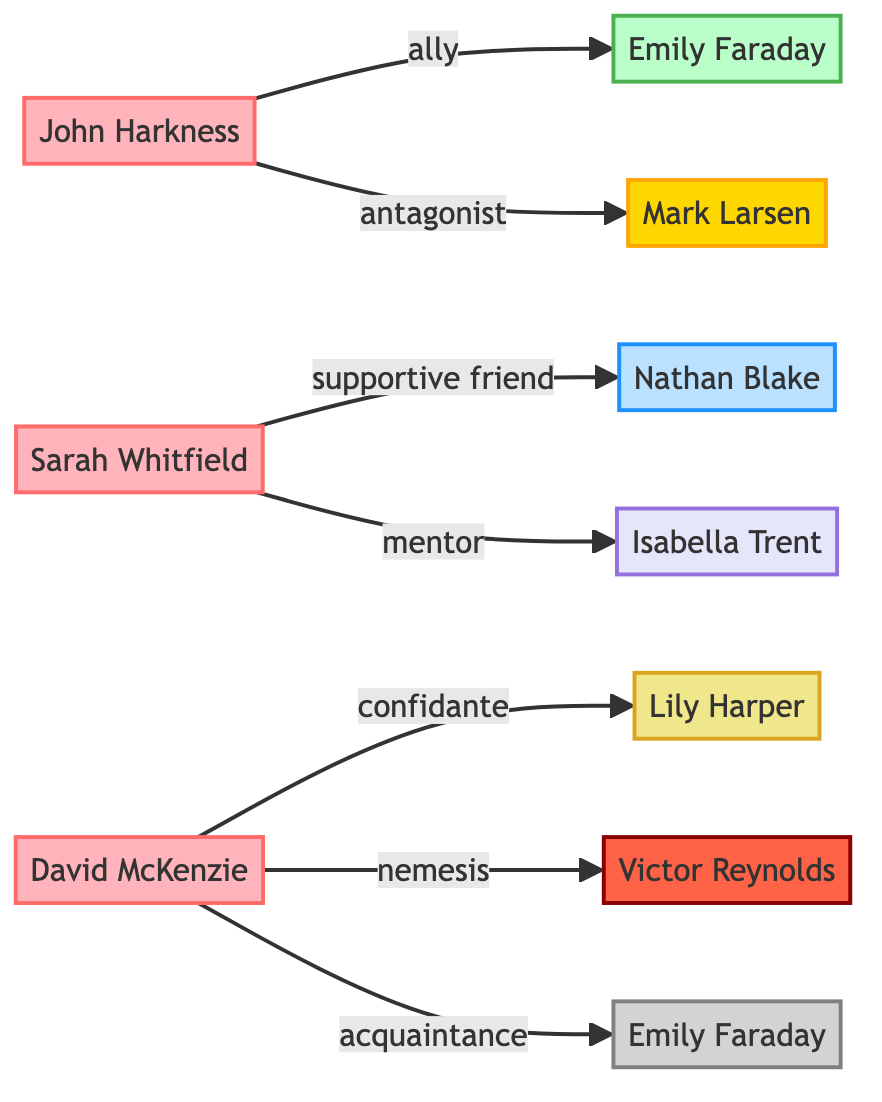What is the total number of nodes in the diagram? The diagram contains a total of 10 unique nodes, representing the characters from David Lord's novels.
Answer: 10 Who is the protagonist in 'The Silent Echo'? The diagram indicates that John Harkness is the protagonist in 'The Silent Echo', as specified in the node details for him.
Answer: John Harkness How many relationships does Sarah Whitfield have in the diagram? Sarah Whitfield has two relationships in the diagram: one as a supportive friend to Nathan Blake and one as a mentee to Isabella Trent.
Answer: 2 What role does Emily Faraday play in 'Eclipse of Souls'? According to the diagram, Emily Faraday appears as a secondary character in 'Eclipse of Souls', as indicated in her node description.
Answer: Secondary character Which character is the nemesis of David McKenzie? The diagram clearly shows that Victor Reynolds is the nemesis of David McKenzie, reflecting their antagonistic relationship in 'Eclipse of Souls'.
Answer: Victor Reynolds What is the relationship between John Harkness and Mark Larsen? The diagram describes John Harkness and Mark Larsen's relationship as antagonist, indicating that Mark Larsen is the opponent of John Harkness in 'The Silent Echo'.
Answer: Antagonist How many mentor relationships are depicted in the diagram? The diagram shows that there is one mentor relationship, which is between Sarah Whitfield and Isabella Trent. Therefore, the count satisfies the requirement for mentors.
Answer: 1 Which character acts as a confidante for David McKenzie? The diagram explicitly states that Lily Harper serves as a confidante for David McKenzie, as indicated in their relationship in the diagram.
Answer: Lily Harper What is the nature of the relationship between Sarah Whitfield and Nathan Blake? The nature of the relationship between Sarah Whitfield and Nathan Blake is defined as supportive friend in the diagram, showing their camaraderie.
Answer: Supportive friend 